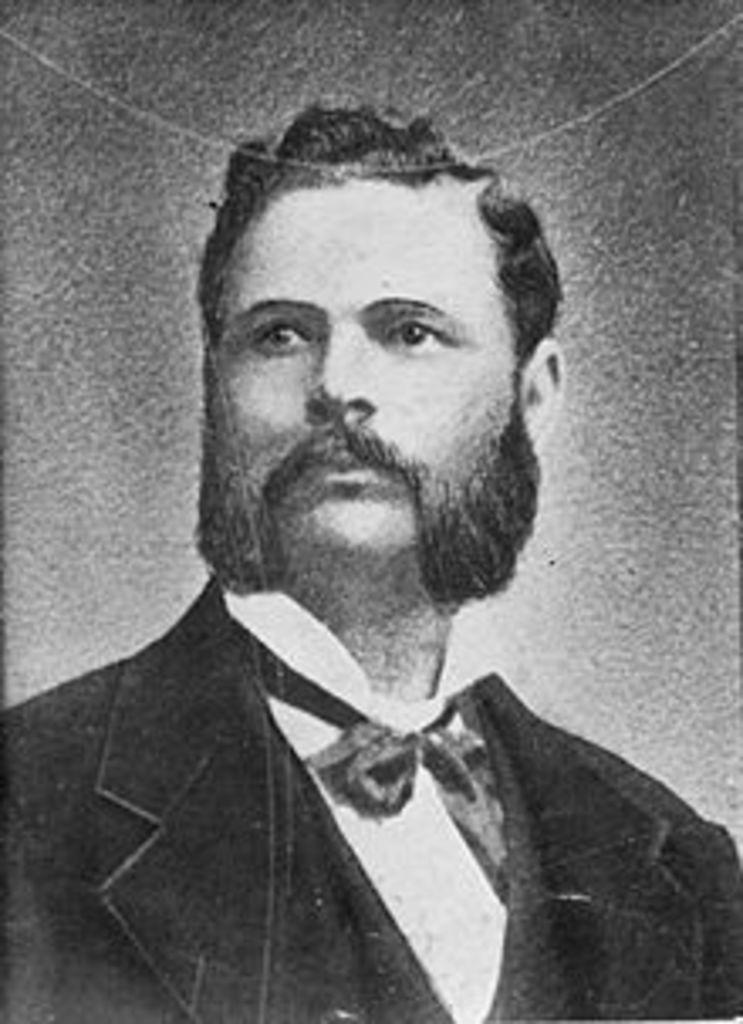Could you give a brief overview of what you see in this image? In this picture we can observe a man wearing a coat and a bow tie. This is a black and white picture. 